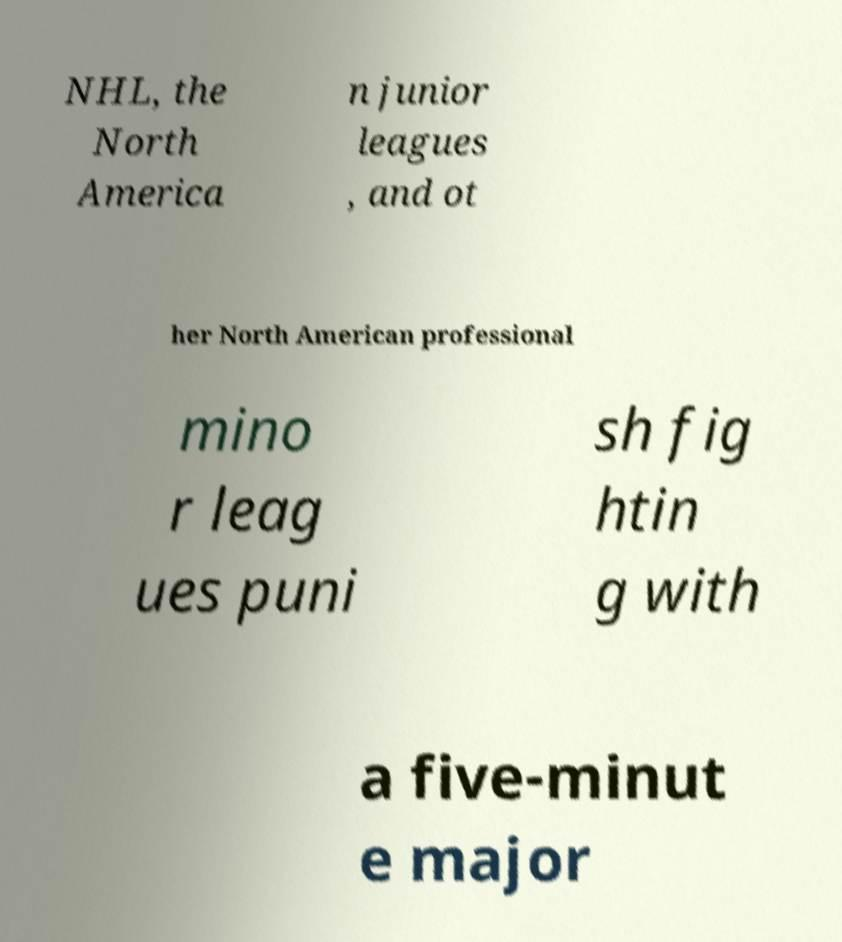Could you extract and type out the text from this image? NHL, the North America n junior leagues , and ot her North American professional mino r leag ues puni sh fig htin g with a five-minut e major 